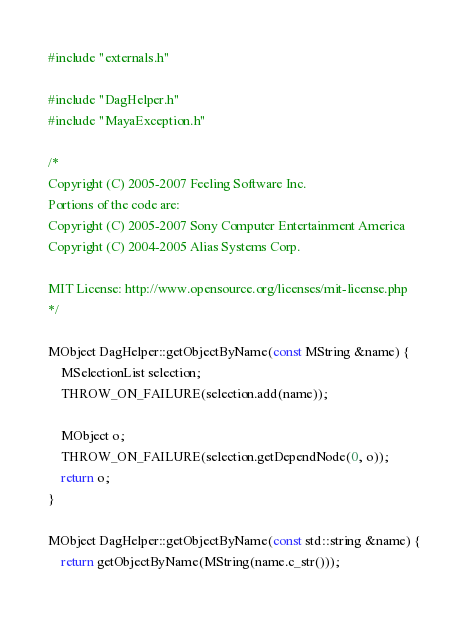Convert code to text. <code><loc_0><loc_0><loc_500><loc_500><_C++_>#include "externals.h"

#include "DagHelper.h"
#include "MayaException.h"

/*
Copyright (C) 2005-2007 Feeling Software Inc.
Portions of the code are:
Copyright (C) 2005-2007 Sony Computer Entertainment America
Copyright (C) 2004-2005 Alias Systems Corp.

MIT License: http://www.opensource.org/licenses/mit-license.php
*/

MObject DagHelper::getObjectByName(const MString &name) {
    MSelectionList selection;
    THROW_ON_FAILURE(selection.add(name));

    MObject o;
    THROW_ON_FAILURE(selection.getDependNode(0, o));
    return o;
}

MObject DagHelper::getObjectByName(const std::string &name) {
    return getObjectByName(MString(name.c_str()));</code> 